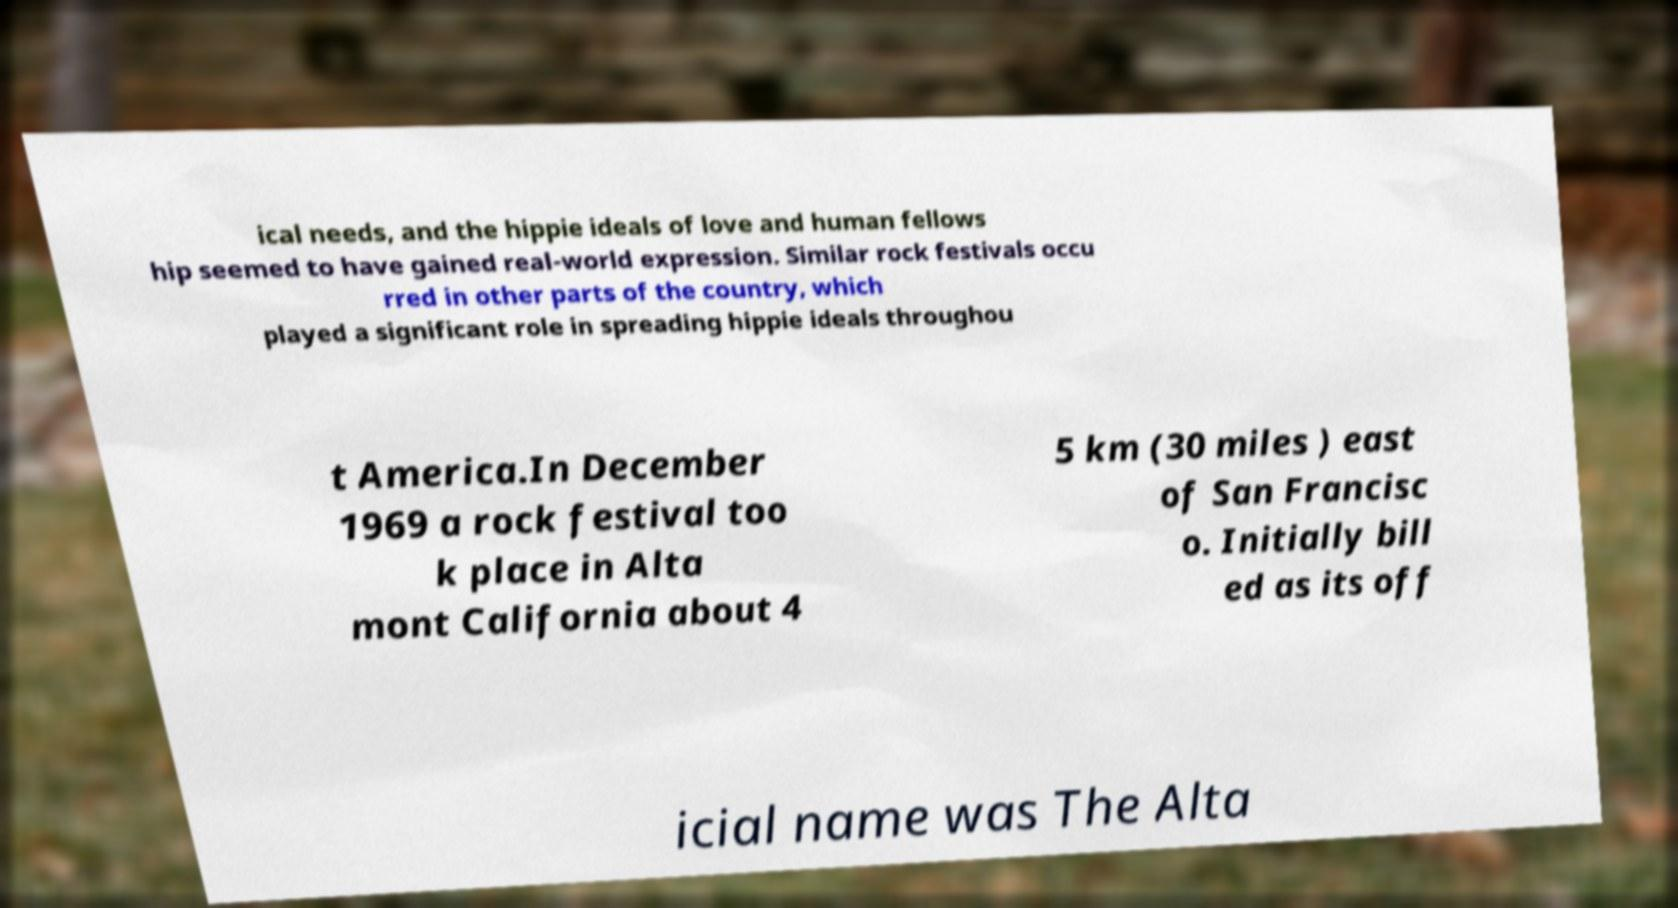Could you extract and type out the text from this image? ical needs, and the hippie ideals of love and human fellows hip seemed to have gained real-world expression. Similar rock festivals occu rred in other parts of the country, which played a significant role in spreading hippie ideals throughou t America.In December 1969 a rock festival too k place in Alta mont California about 4 5 km (30 miles ) east of San Francisc o. Initially bill ed as its off icial name was The Alta 